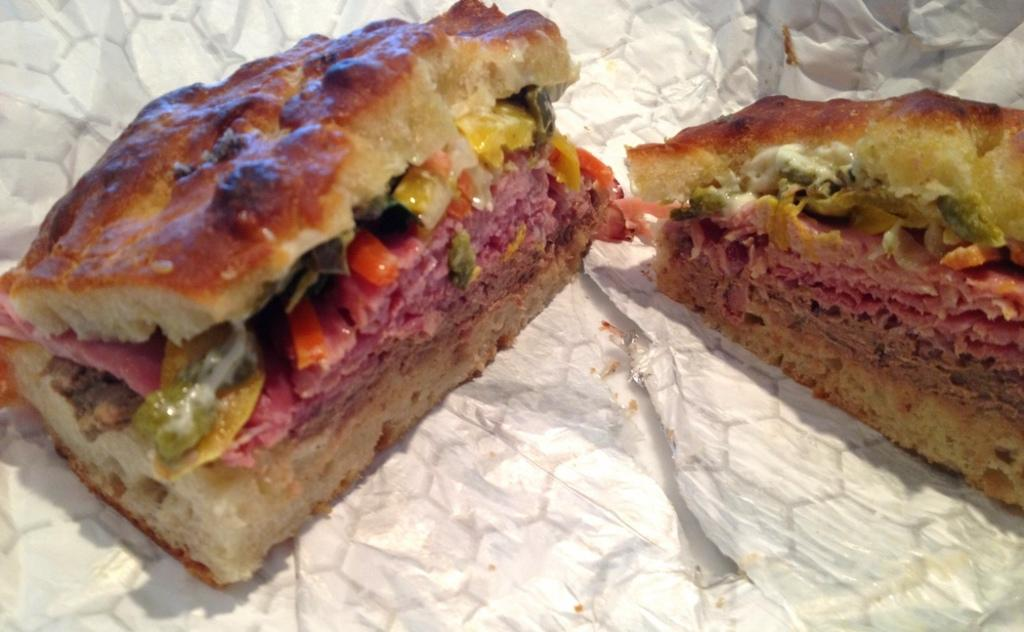What is present in the image? There are food items in the image. How are the food items arranged or presented? The food items are on a paper. What type of apples can be seen on the seat in the image? There are no apples or seats present in the image; it only features food items on a paper. 